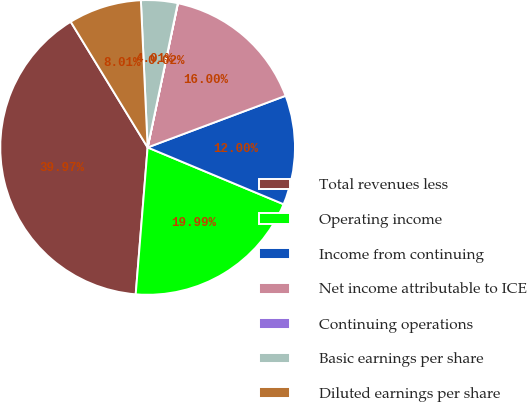Convert chart to OTSL. <chart><loc_0><loc_0><loc_500><loc_500><pie_chart><fcel>Total revenues less<fcel>Operating income<fcel>Income from continuing<fcel>Net income attributable to ICE<fcel>Continuing operations<fcel>Basic earnings per share<fcel>Diluted earnings per share<nl><fcel>39.97%<fcel>19.99%<fcel>12.0%<fcel>16.0%<fcel>0.02%<fcel>4.01%<fcel>8.01%<nl></chart> 